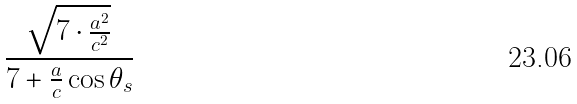Convert formula to latex. <formula><loc_0><loc_0><loc_500><loc_500>\frac { \sqrt { 7 \cdot \frac { a ^ { 2 } } { c ^ { 2 } } } } { 7 + \frac { a } { c } \cos \theta _ { s } }</formula> 